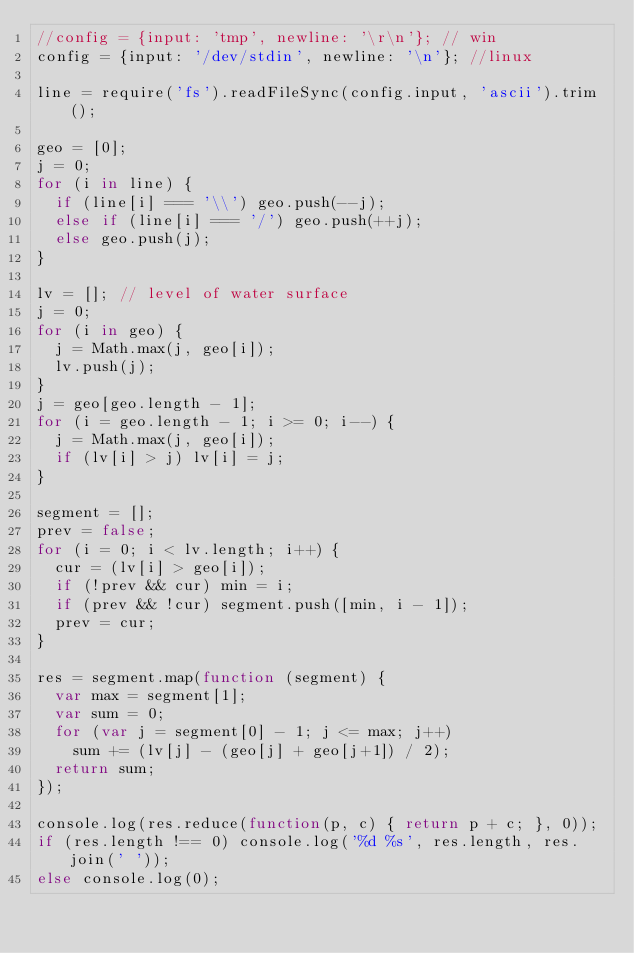Convert code to text. <code><loc_0><loc_0><loc_500><loc_500><_JavaScript_>//config = {input: 'tmp', newline: '\r\n'}; // win
config = {input: '/dev/stdin', newline: '\n'}; //linux

line = require('fs').readFileSync(config.input, 'ascii').trim();

geo = [0];
j = 0;
for (i in line) {
  if (line[i] === '\\') geo.push(--j);
  else if (line[i] === '/') geo.push(++j);
  else geo.push(j);
}

lv = []; // level of water surface
j = 0;
for (i in geo) {
  j = Math.max(j, geo[i]);
  lv.push(j);
}
j = geo[geo.length - 1];
for (i = geo.length - 1; i >= 0; i--) {
  j = Math.max(j, geo[i]);
  if (lv[i] > j) lv[i] = j;
}

segment = [];
prev = false;
for (i = 0; i < lv.length; i++) {
  cur = (lv[i] > geo[i]);
  if (!prev && cur) min = i;
  if (prev && !cur) segment.push([min, i - 1]);
  prev = cur;
}

res = segment.map(function (segment) {
  var max = segment[1];
  var sum = 0;
  for (var j = segment[0] - 1; j <= max; j++)
    sum += (lv[j] - (geo[j] + geo[j+1]) / 2);
  return sum;
});

console.log(res.reduce(function(p, c) { return p + c; }, 0));
if (res.length !== 0) console.log('%d %s', res.length, res.join(' '));
else console.log(0);</code> 